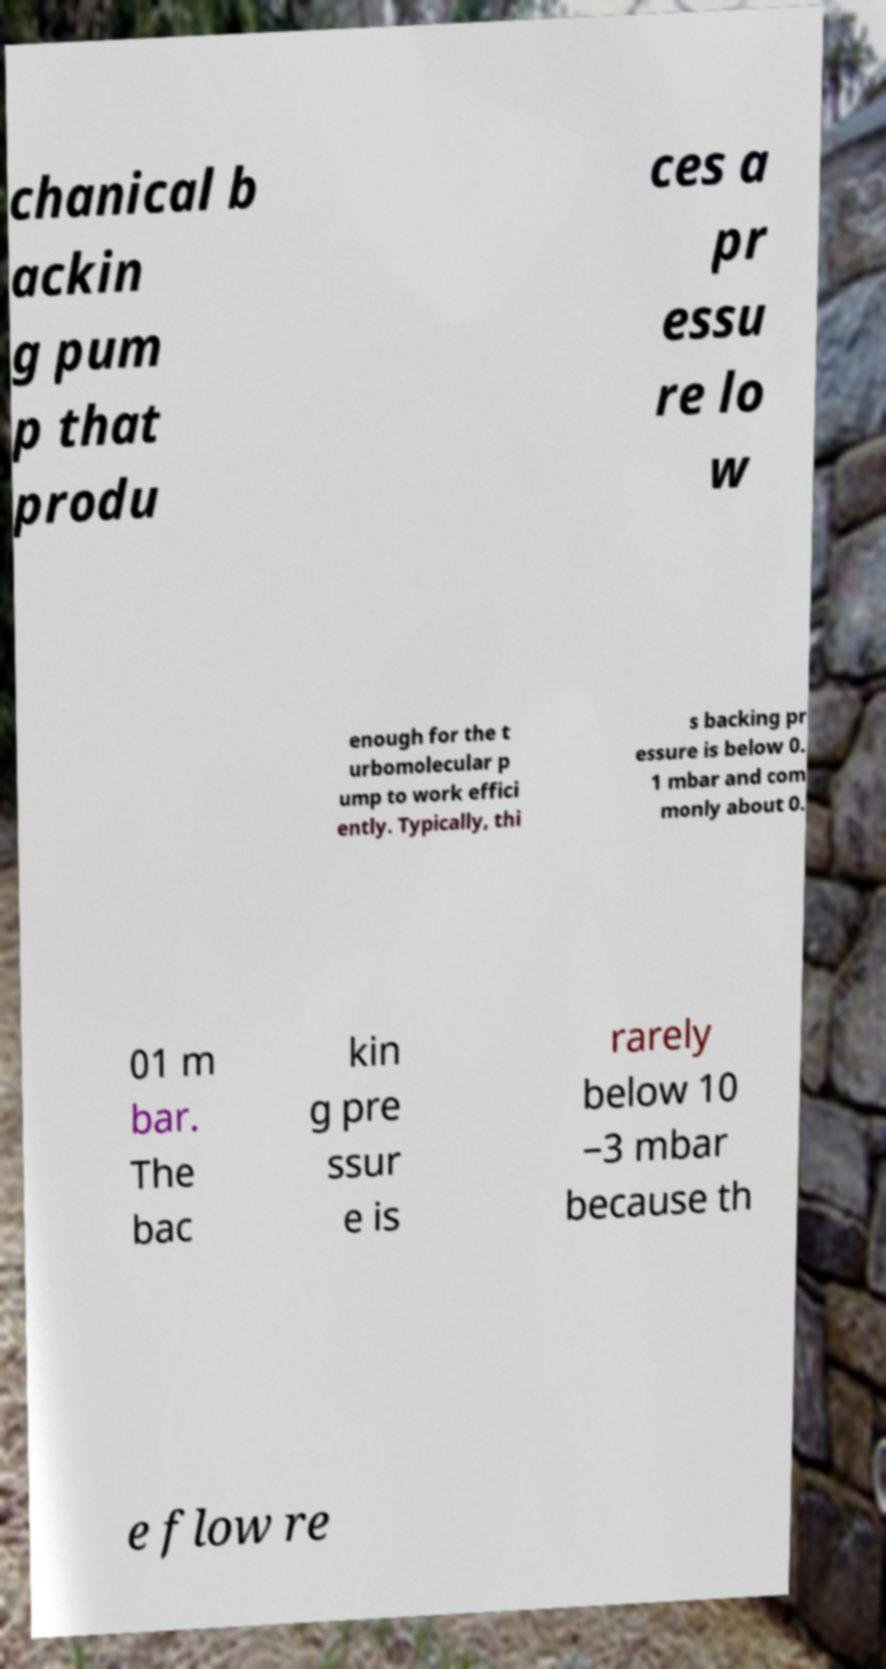Please identify and transcribe the text found in this image. chanical b ackin g pum p that produ ces a pr essu re lo w enough for the t urbomolecular p ump to work effici ently. Typically, thi s backing pr essure is below 0. 1 mbar and com monly about 0. 01 m bar. The bac kin g pre ssur e is rarely below 10 −3 mbar because th e flow re 